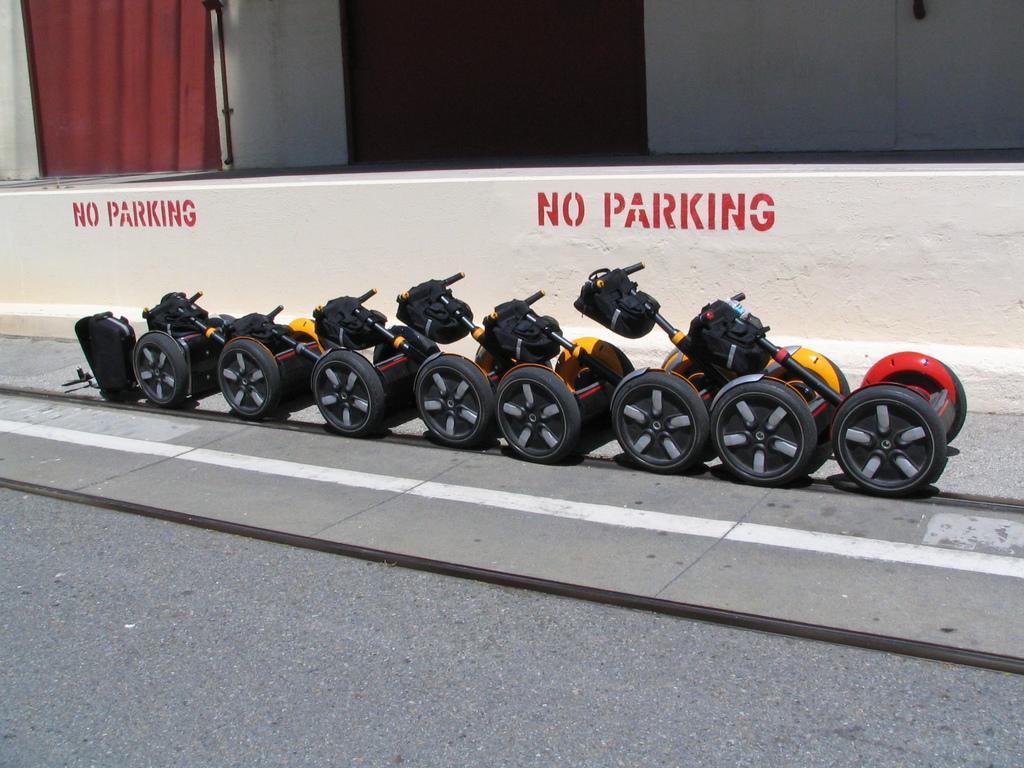Can you describe this image briefly? This picture shows few self-balancing scooters on the side of the road and we see a building. 